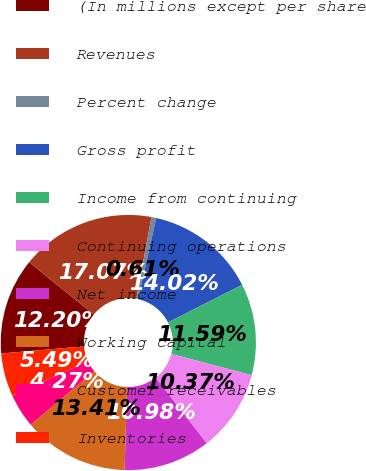<chart> <loc_0><loc_0><loc_500><loc_500><pie_chart><fcel>(In millions except per share<fcel>Revenues<fcel>Percent change<fcel>Gross profit<fcel>Income from continuing<fcel>Continuing operations<fcel>Net income<fcel>Working capital<fcel>Customer receivables<fcel>Inventories<nl><fcel>12.2%<fcel>17.07%<fcel>0.61%<fcel>14.02%<fcel>11.59%<fcel>10.37%<fcel>10.98%<fcel>13.41%<fcel>4.27%<fcel>5.49%<nl></chart> 